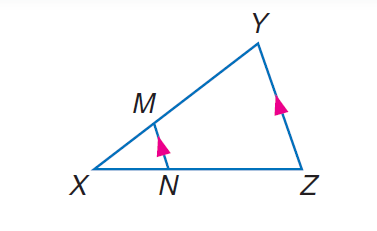Answer the mathemtical geometry problem and directly provide the correct option letter.
Question: If X M = 4, X N = 6, and N Z = 9, find X Y.
Choices: A: 5 B: 10 C: 13 D: 15 B 